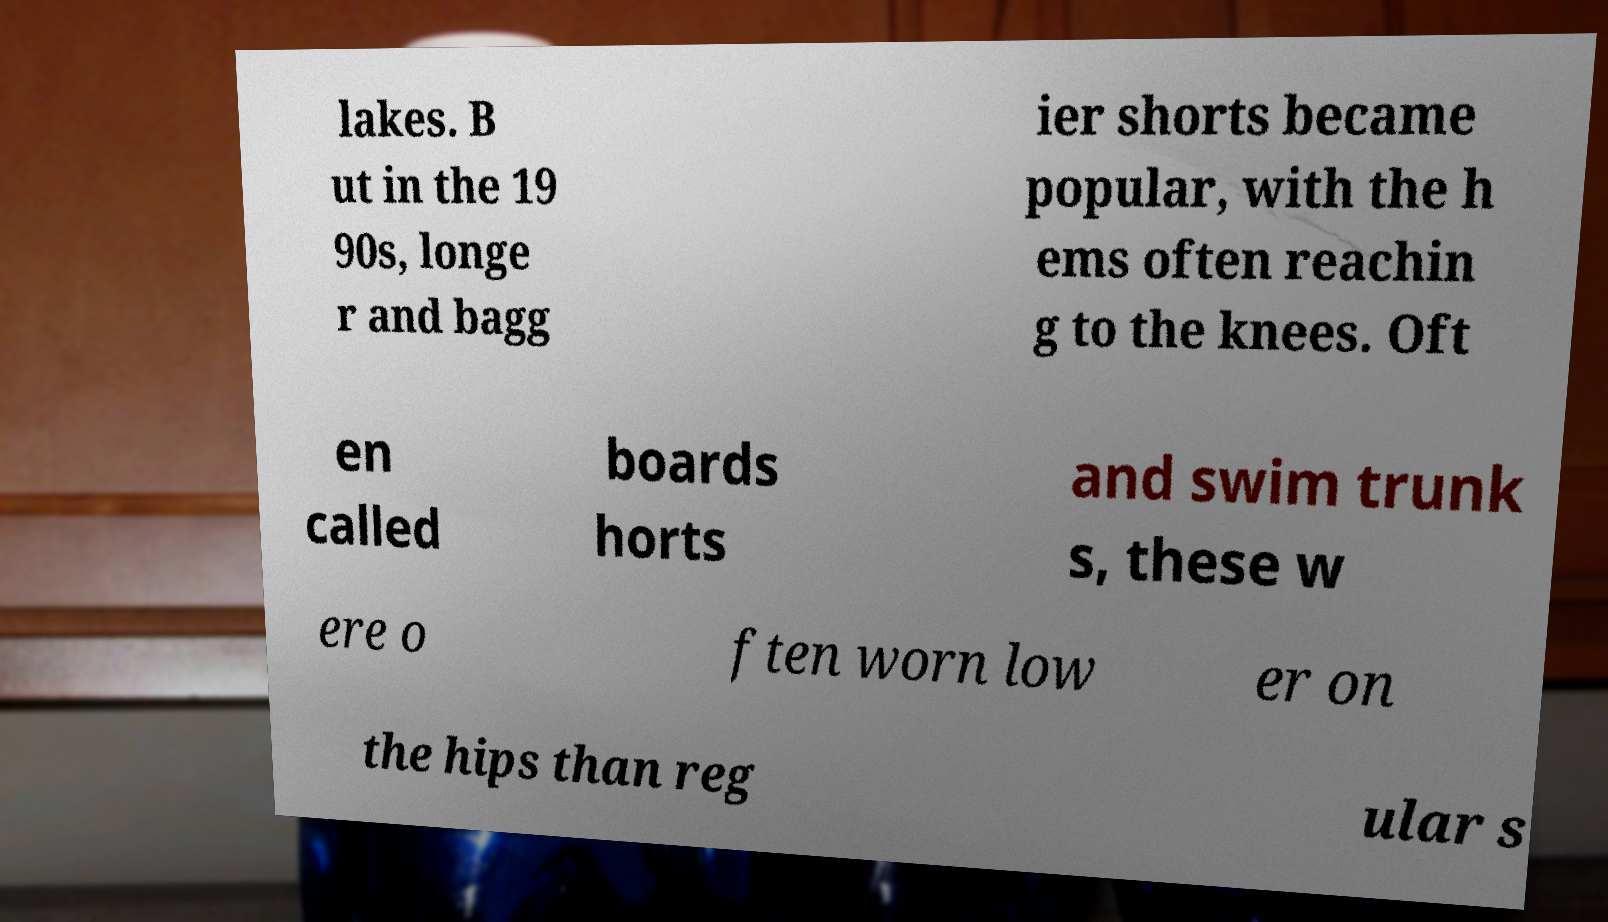Can you accurately transcribe the text from the provided image for me? lakes. B ut in the 19 90s, longe r and bagg ier shorts became popular, with the h ems often reachin g to the knees. Oft en called boards horts and swim trunk s, these w ere o ften worn low er on the hips than reg ular s 